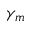<formula> <loc_0><loc_0><loc_500><loc_500>\gamma _ { m }</formula> 